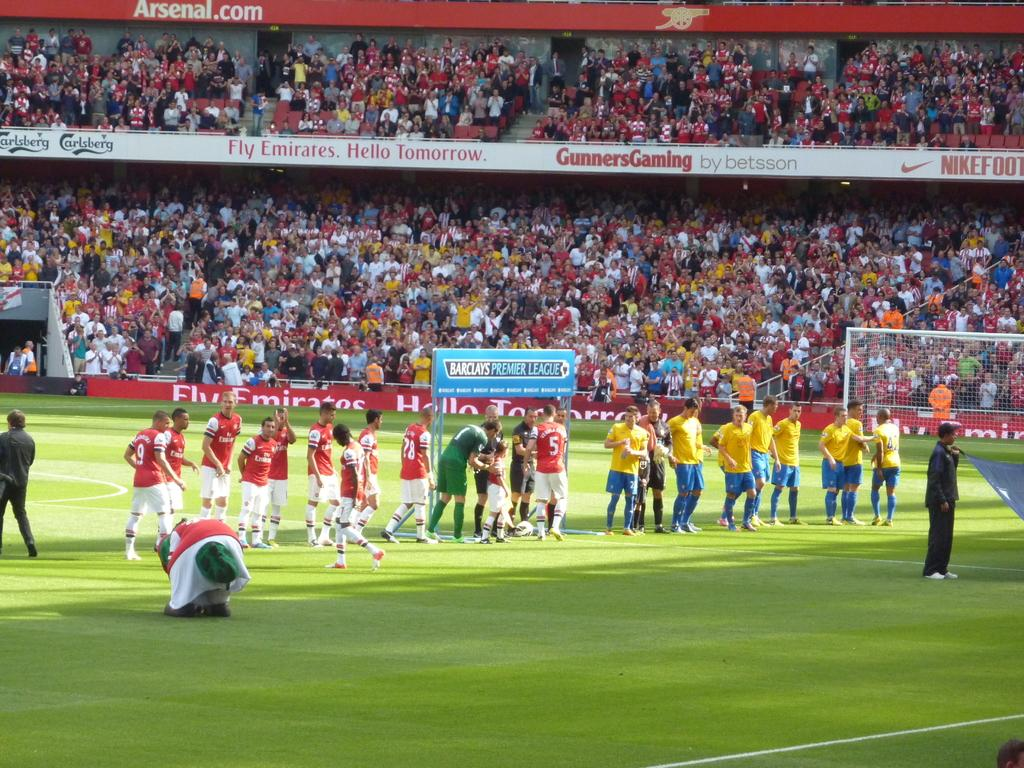<image>
Give a short and clear explanation of the subsequent image. A line of athletes on a field sponsored by Emirates Airlines. 